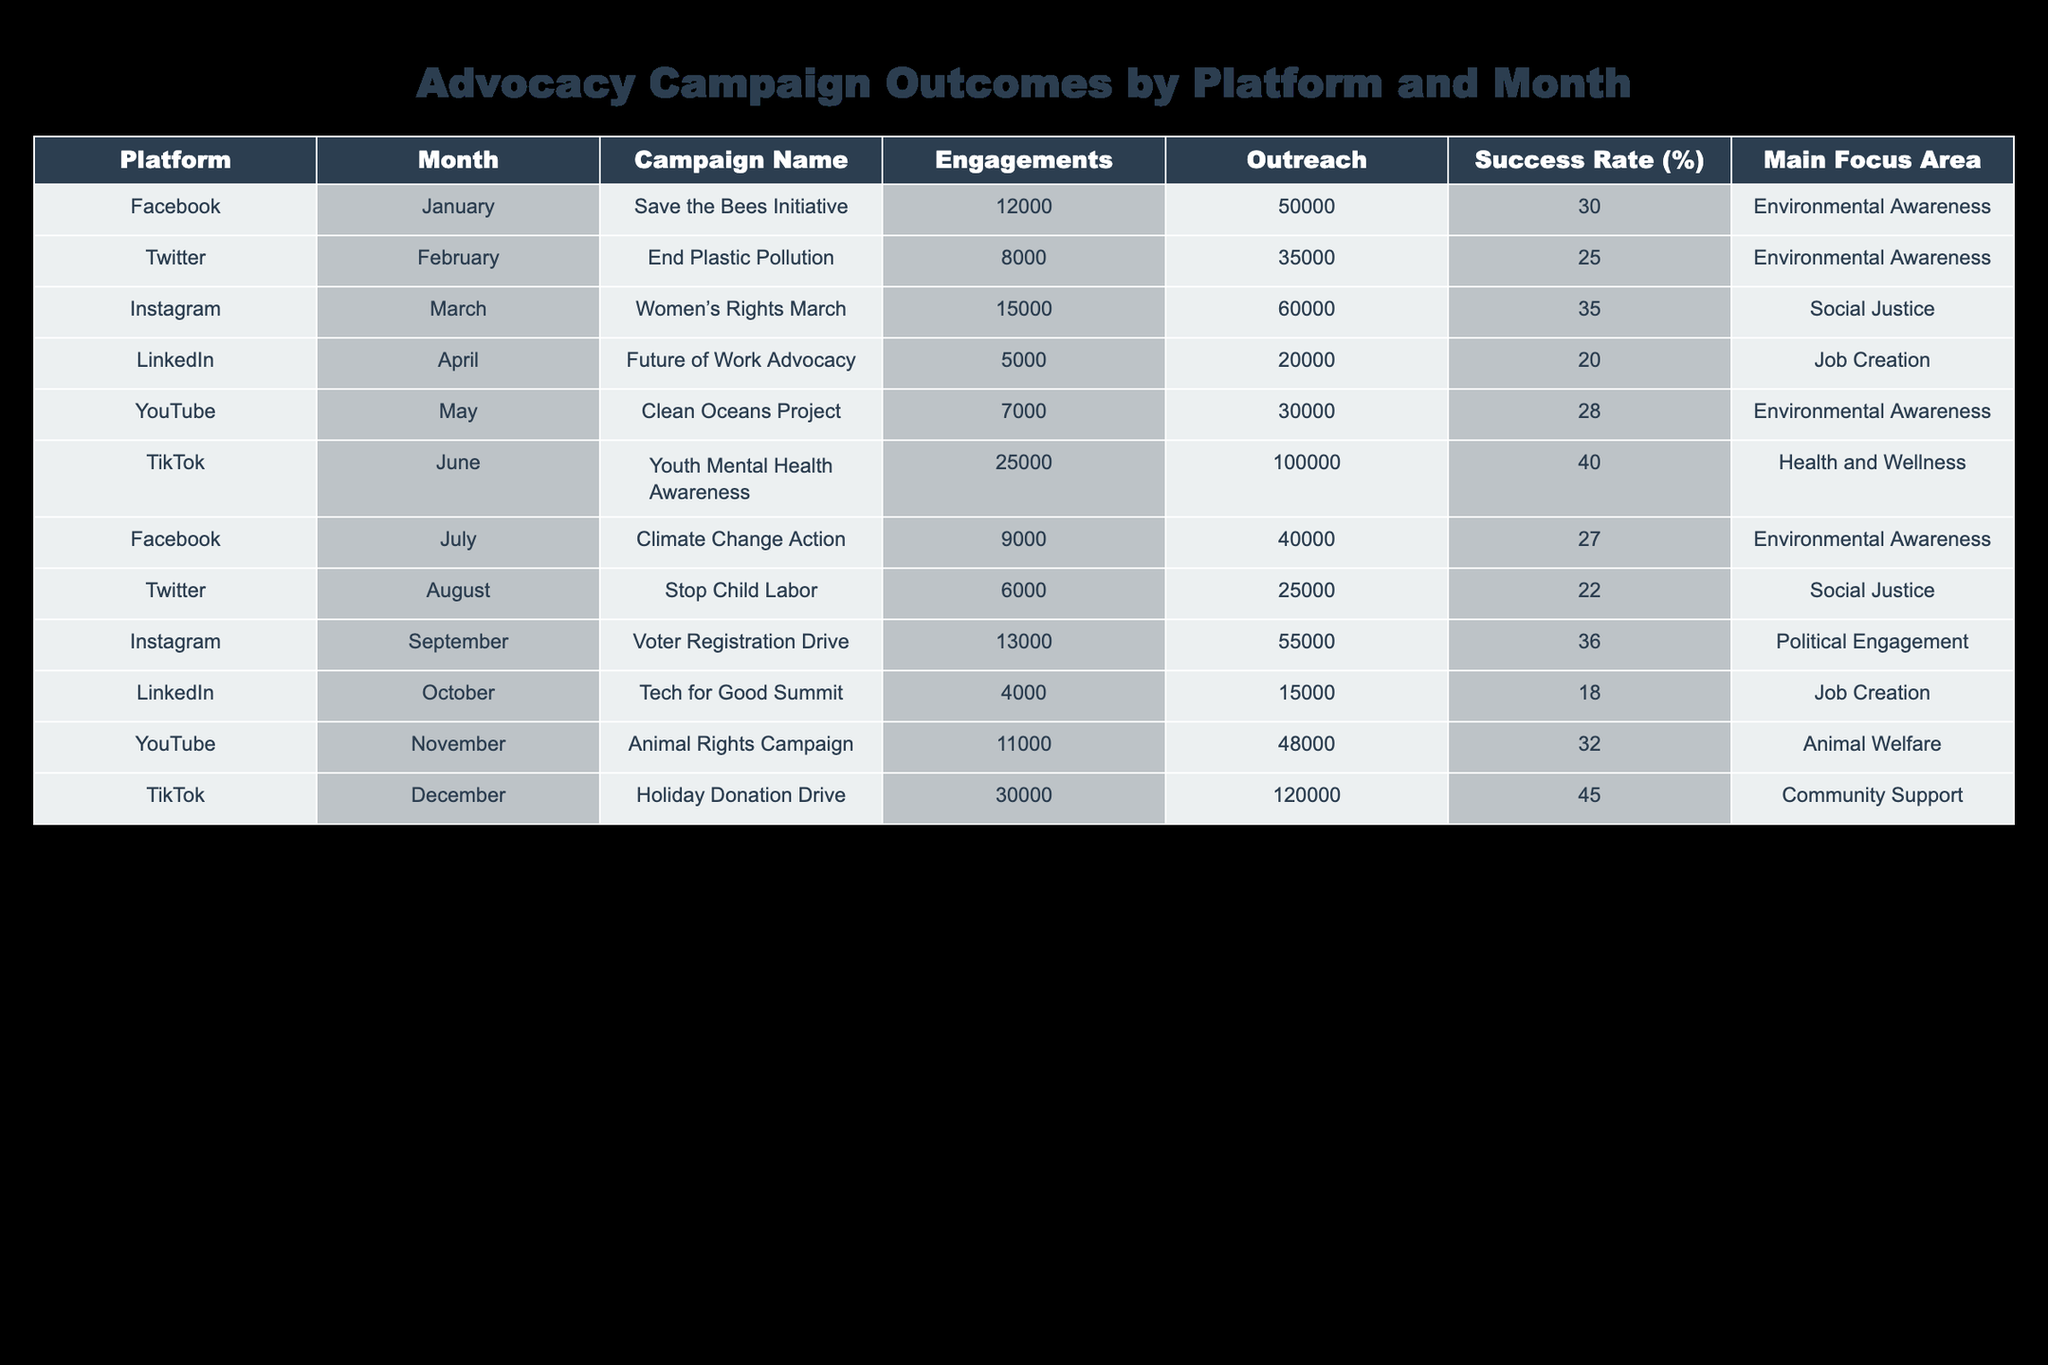What was the campaign with the highest engagement? By reviewing the "Engagements" column, we see that the "Youth Mental Health Awareness" campaign on TikTok had the highest number of engagements at 25,000.
Answer: 25,000 Which platform had the lowest success rate? Looking at the "Success Rate (%)" column, the "Tech for Good Summit" campaign on LinkedIn has the lowest success rate at 18%.
Answer: 18% How many total engagements did the campaigns on Instagram generate? From the "Engagements" column, the Instagram campaigns are "Women's Rights March" (15,000) and "Voter Registration Drive" (13,000). Adding these gives us 15,000 + 13,000 = 28,000 total engagements.
Answer: 28,000 Did Facebook have a campaign with more than 10,000 engagements? Checking the "Engagements" column, the "Save the Bees Initiative" had 12,000 engagements, so yes, Facebook had a campaign exceeding 10,000 engagements.
Answer: Yes What is the average outreach for TikTok campaigns? The outreach values for TikTok campaigns are 100,000 (Youth Mental Health Awareness) and 120,000 (Holiday Donation Drive). To find the average, we sum these values: 100,000 + 120,000 = 220,000. Then, divide by the number of campaigns (2): 220,000 / 2 = 110,000.
Answer: 110,000 Which campaign had a main focus area of "Health and Wellness"? The "Youth Mental Health Awareness" campaign on TikTok had "Health and Wellness" as its main focus area.
Answer: Youth Mental Health Awareness How many campaigns had a success rate of 30% or higher? By reviewing the "Success Rate (%)" column, the campaigns with a 30% or higher success rate are: "Save the Bees Initiative" (30%), "Women's Rights March" (35%), "TikTok Youth Mental Health Awareness" (40%), "September Voter Registration Drive" (36%), and "Holiday Donation Drive" (45%). This totals five campaigns.
Answer: 5 